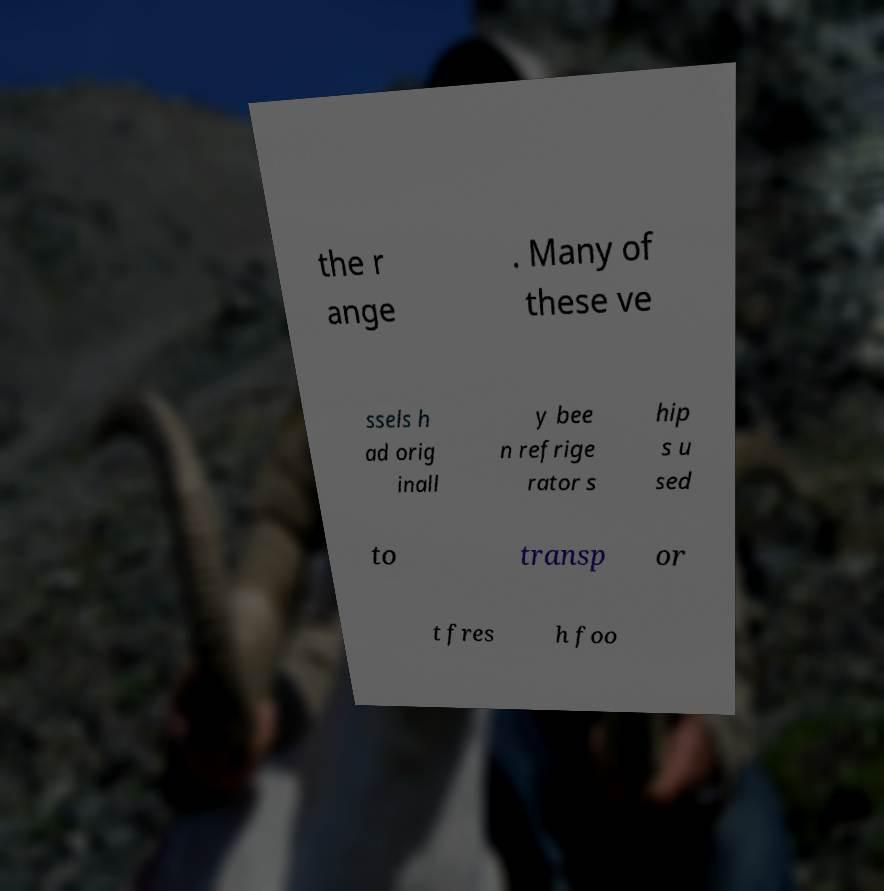What messages or text are displayed in this image? I need them in a readable, typed format. the r ange . Many of these ve ssels h ad orig inall y bee n refrige rator s hip s u sed to transp or t fres h foo 